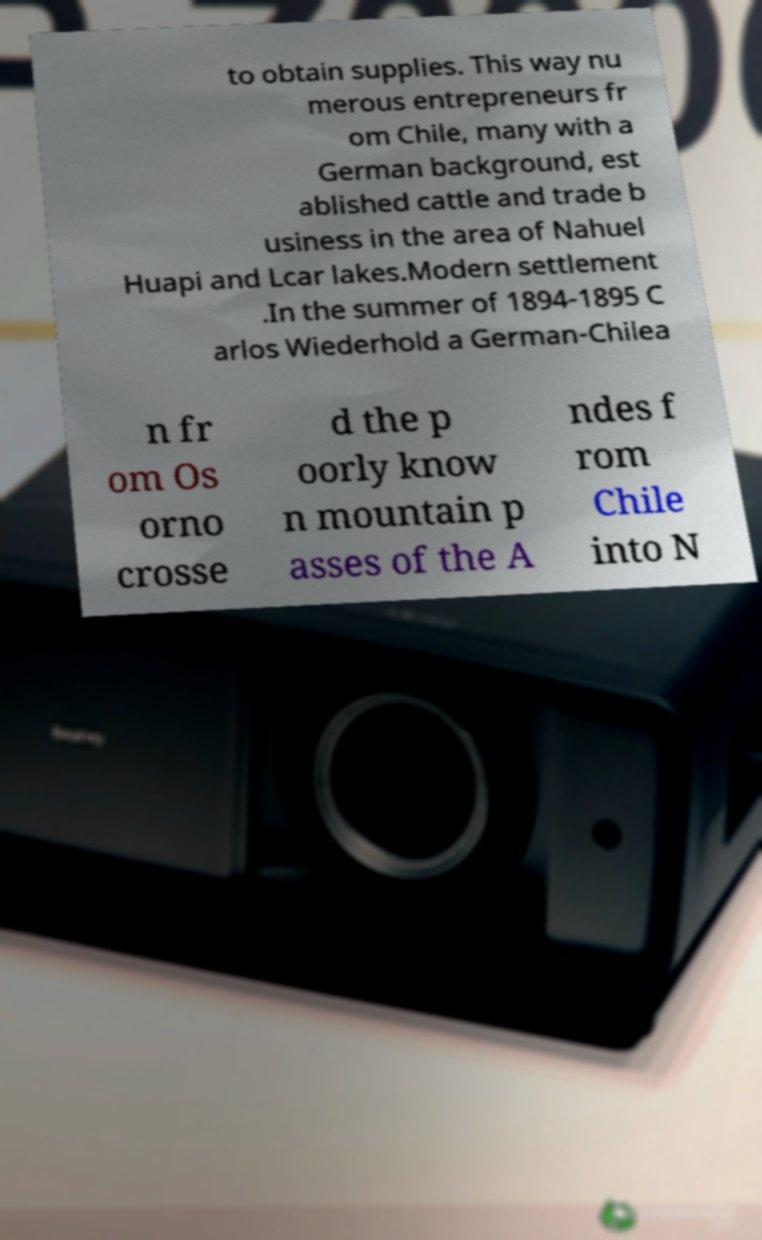I need the written content from this picture converted into text. Can you do that? to obtain supplies. This way nu merous entrepreneurs fr om Chile, many with a German background, est ablished cattle and trade b usiness in the area of Nahuel Huapi and Lcar lakes.Modern settlement .In the summer of 1894-1895 C arlos Wiederhold a German-Chilea n fr om Os orno crosse d the p oorly know n mountain p asses of the A ndes f rom Chile into N 